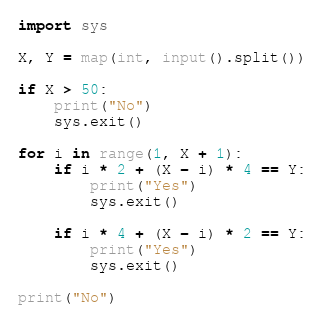<code> <loc_0><loc_0><loc_500><loc_500><_Python_>import sys

X, Y = map(int, input().split())

if X > 50:
    print("No")
    sys.exit()

for i in range(1, X + 1):
    if i * 2 + (X - i) * 4 == Y:
        print("Yes")
        sys.exit()

    if i * 4 + (X - i) * 2 == Y:
        print("Yes")
        sys.exit()

print("No")
</code> 